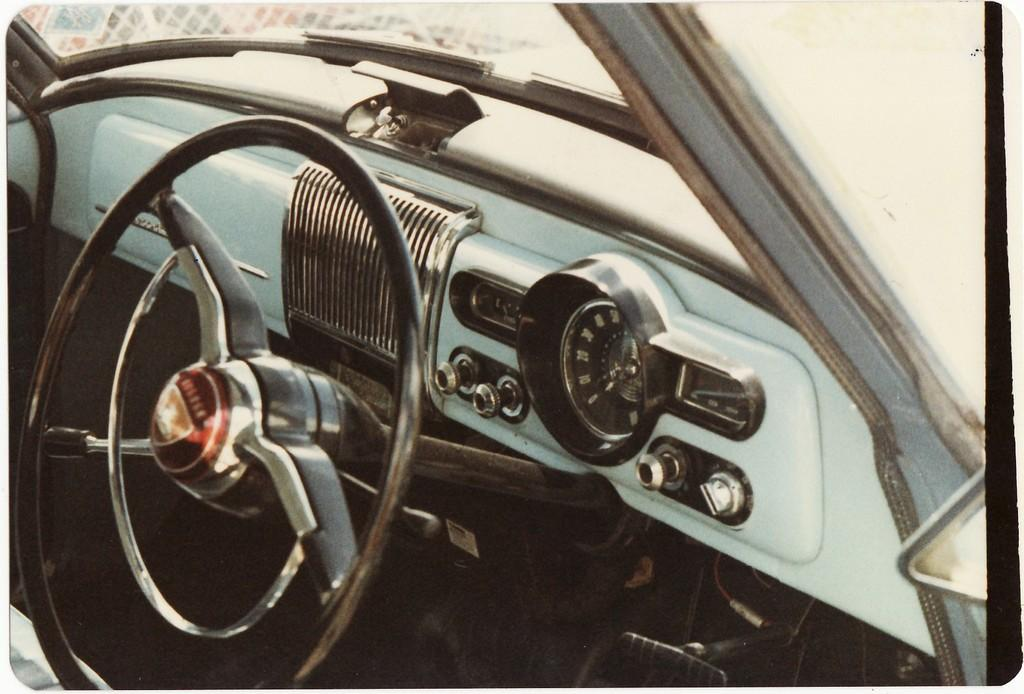What is the main subject of the picture? The main subject of the picture is a car. What feature is present inside the car? The car has a steering wheel. What type of sock is hanging from the rearview mirror in the image? There is no sock present in the image; it is a picture of a car with a steering wheel. 